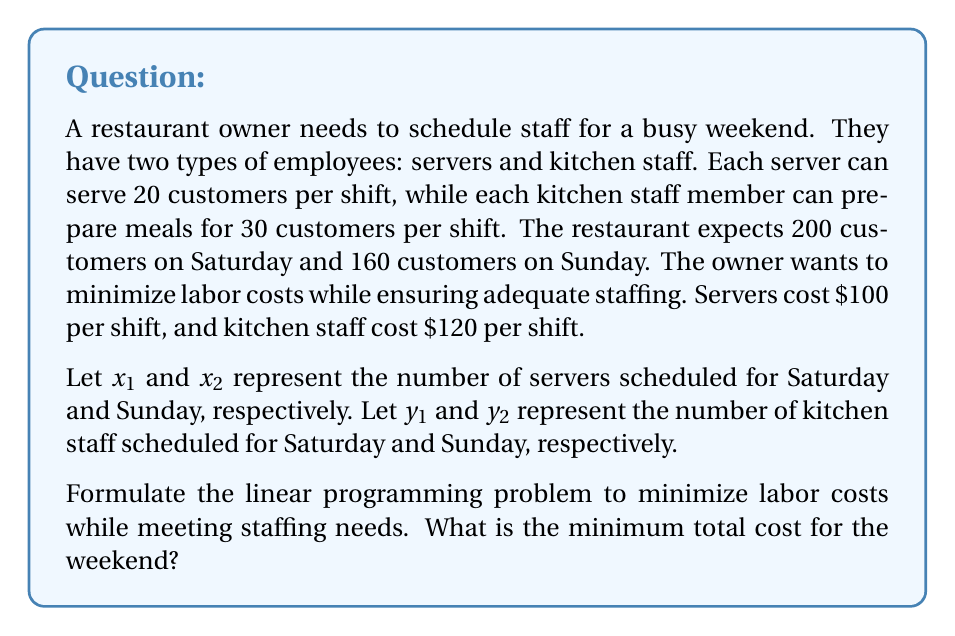Solve this math problem. To solve this problem, we need to set up the linear programming model and then solve it. Let's break it down step by step:

1. Objective function:
   We want to minimize the total cost, which is the sum of all staff costs for both days.
   $$\text{Minimize } Z = 100(x_1 + x_2) + 120(y_1 + y_2)$$

2. Constraints:
   a) Saturday staffing (200 customers):
      $$20x_1 + 30y_1 \geq 200$$
   b) Sunday staffing (160 customers):
      $$20x_2 + 30y_2 \geq 160$$
   c) Non-negativity constraints:
      $$x_1, x_2, y_1, y_2 \geq 0$$

3. Solving the linear programming problem:
   We can solve this using the simplex method or linear programming software. However, for this problem, we can use a simpler approach due to its structure.

   For each day, we need to find the minimum number of staff that satisfies the constraint:

   a) For Saturday:
      $20x_1 + 30y_1 = 200$
      We can satisfy this with 10 servers $(x_1 = 10)$ or 7 kitchen staff $(y_1 = \frac{20}{3})$.
      Since kitchen staff are more expensive, we'll use servers: $x_1 = 10, y_1 = 0$

   b) For Sunday:
      $20x_2 + 30y_2 = 160$
      We can satisfy this with 8 servers $(x_2 = 8)$ or 6 kitchen staff $(y_2 = \frac{16}{3})$.
      Again, we'll use servers: $x_2 = 8, y_2 = 0$

4. Calculating the total cost:
   $$Z = 100(10 + 8) + 120(0 + 0) = 1800$$

Therefore, the minimum total cost for the weekend is $1800.
Answer: The minimum total labor cost for the weekend is $1800. 